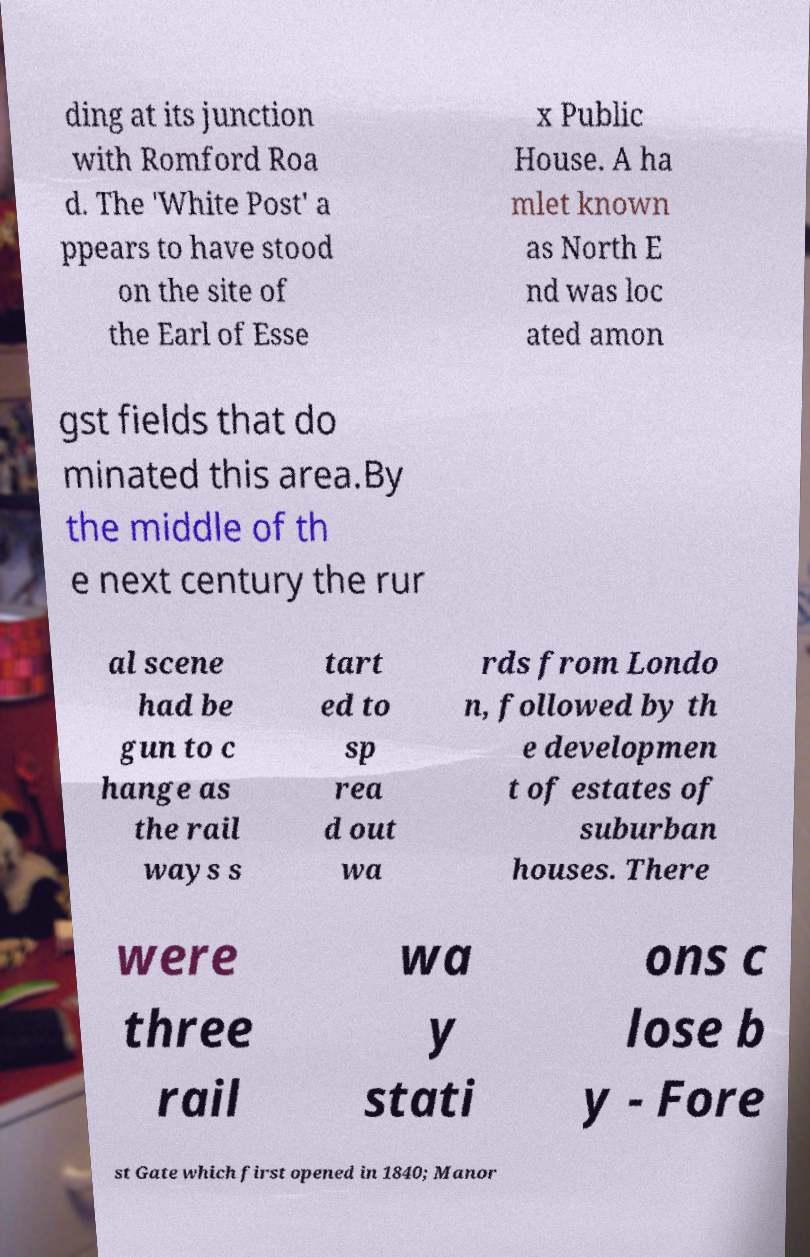Please identify and transcribe the text found in this image. ding at its junction with Romford Roa d. The 'White Post' a ppears to have stood on the site of the Earl of Esse x Public House. A ha mlet known as North E nd was loc ated amon gst fields that do minated this area.By the middle of th e next century the rur al scene had be gun to c hange as the rail ways s tart ed to sp rea d out wa rds from Londo n, followed by th e developmen t of estates of suburban houses. There were three rail wa y stati ons c lose b y - Fore st Gate which first opened in 1840; Manor 